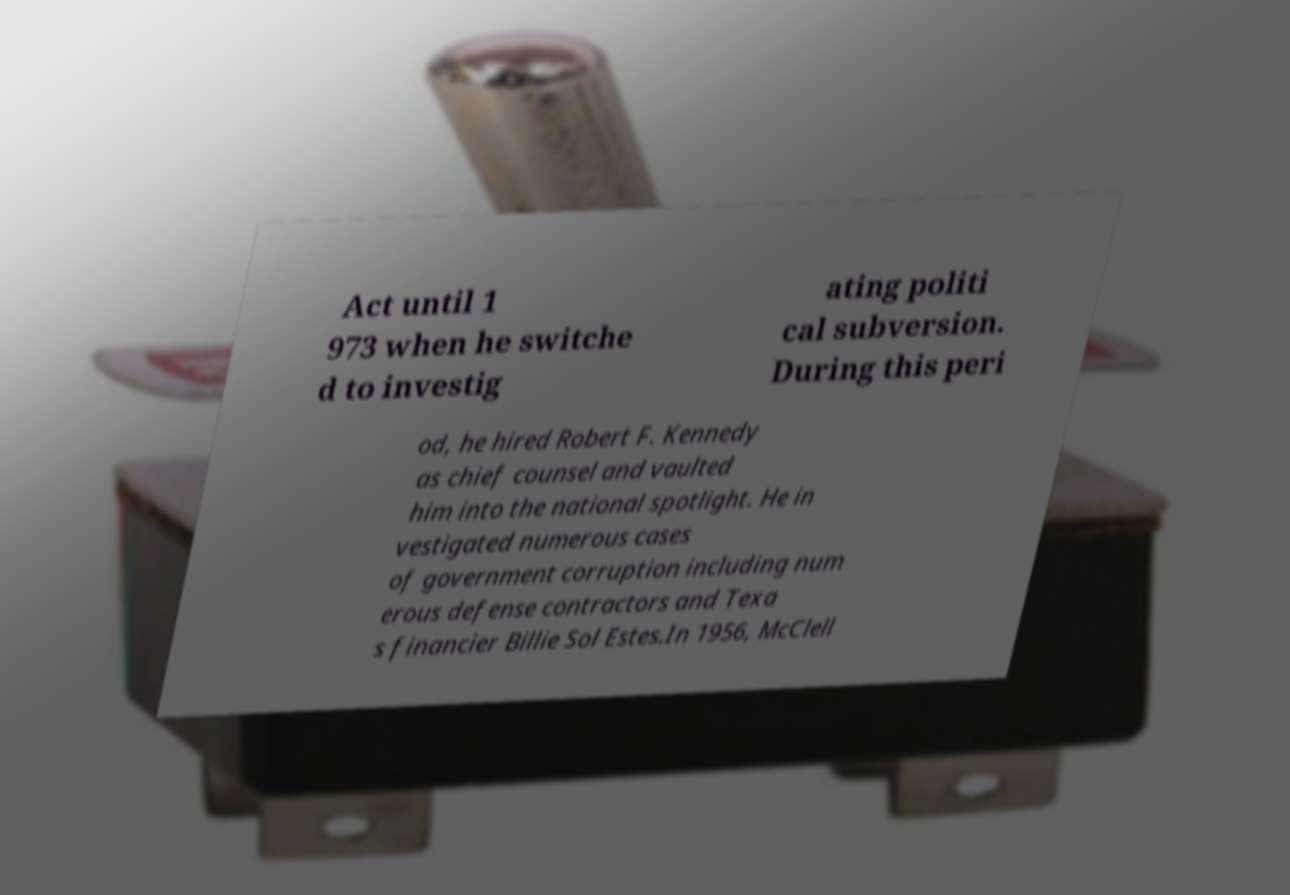Can you read and provide the text displayed in the image?This photo seems to have some interesting text. Can you extract and type it out for me? Act until 1 973 when he switche d to investig ating politi cal subversion. During this peri od, he hired Robert F. Kennedy as chief counsel and vaulted him into the national spotlight. He in vestigated numerous cases of government corruption including num erous defense contractors and Texa s financier Billie Sol Estes.In 1956, McClell 